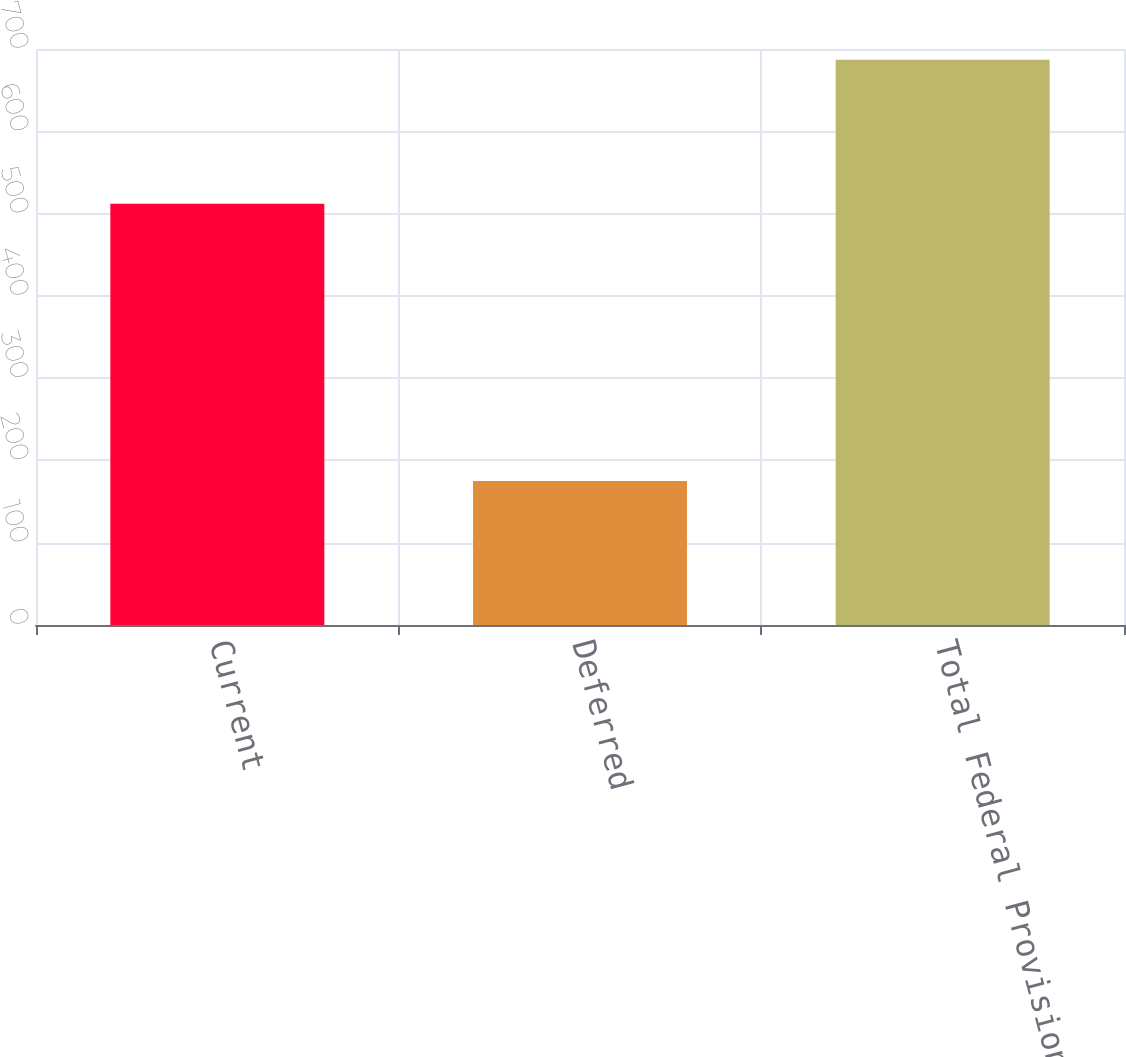<chart> <loc_0><loc_0><loc_500><loc_500><bar_chart><fcel>Current<fcel>Deferred<fcel>Total Federal Provision<nl><fcel>512<fcel>175<fcel>687<nl></chart> 